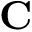Convert formula to latex. <formula><loc_0><loc_0><loc_500><loc_500>C</formula> 